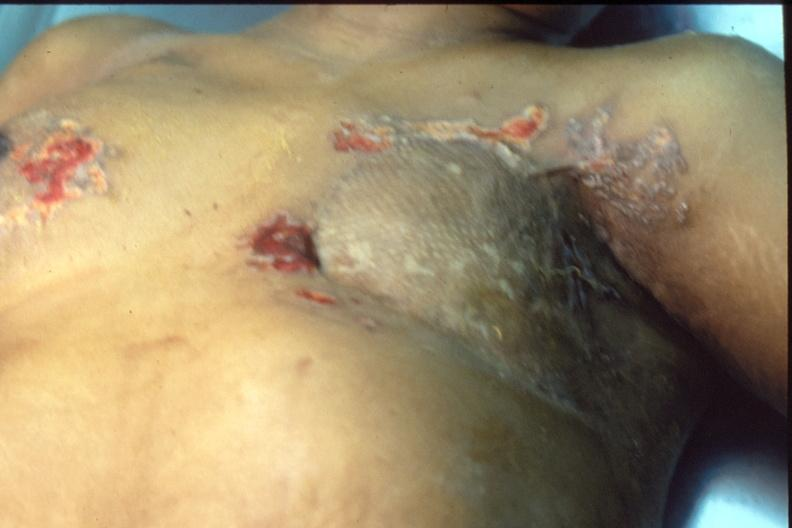s very good example present?
Answer the question using a single word or phrase. No 